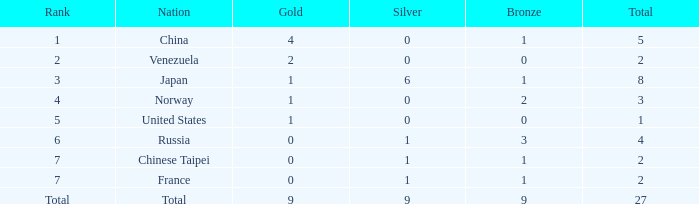When taking the nation's total and there are more than 1 gold, what is the complete quantity of bronze? 1.0. 